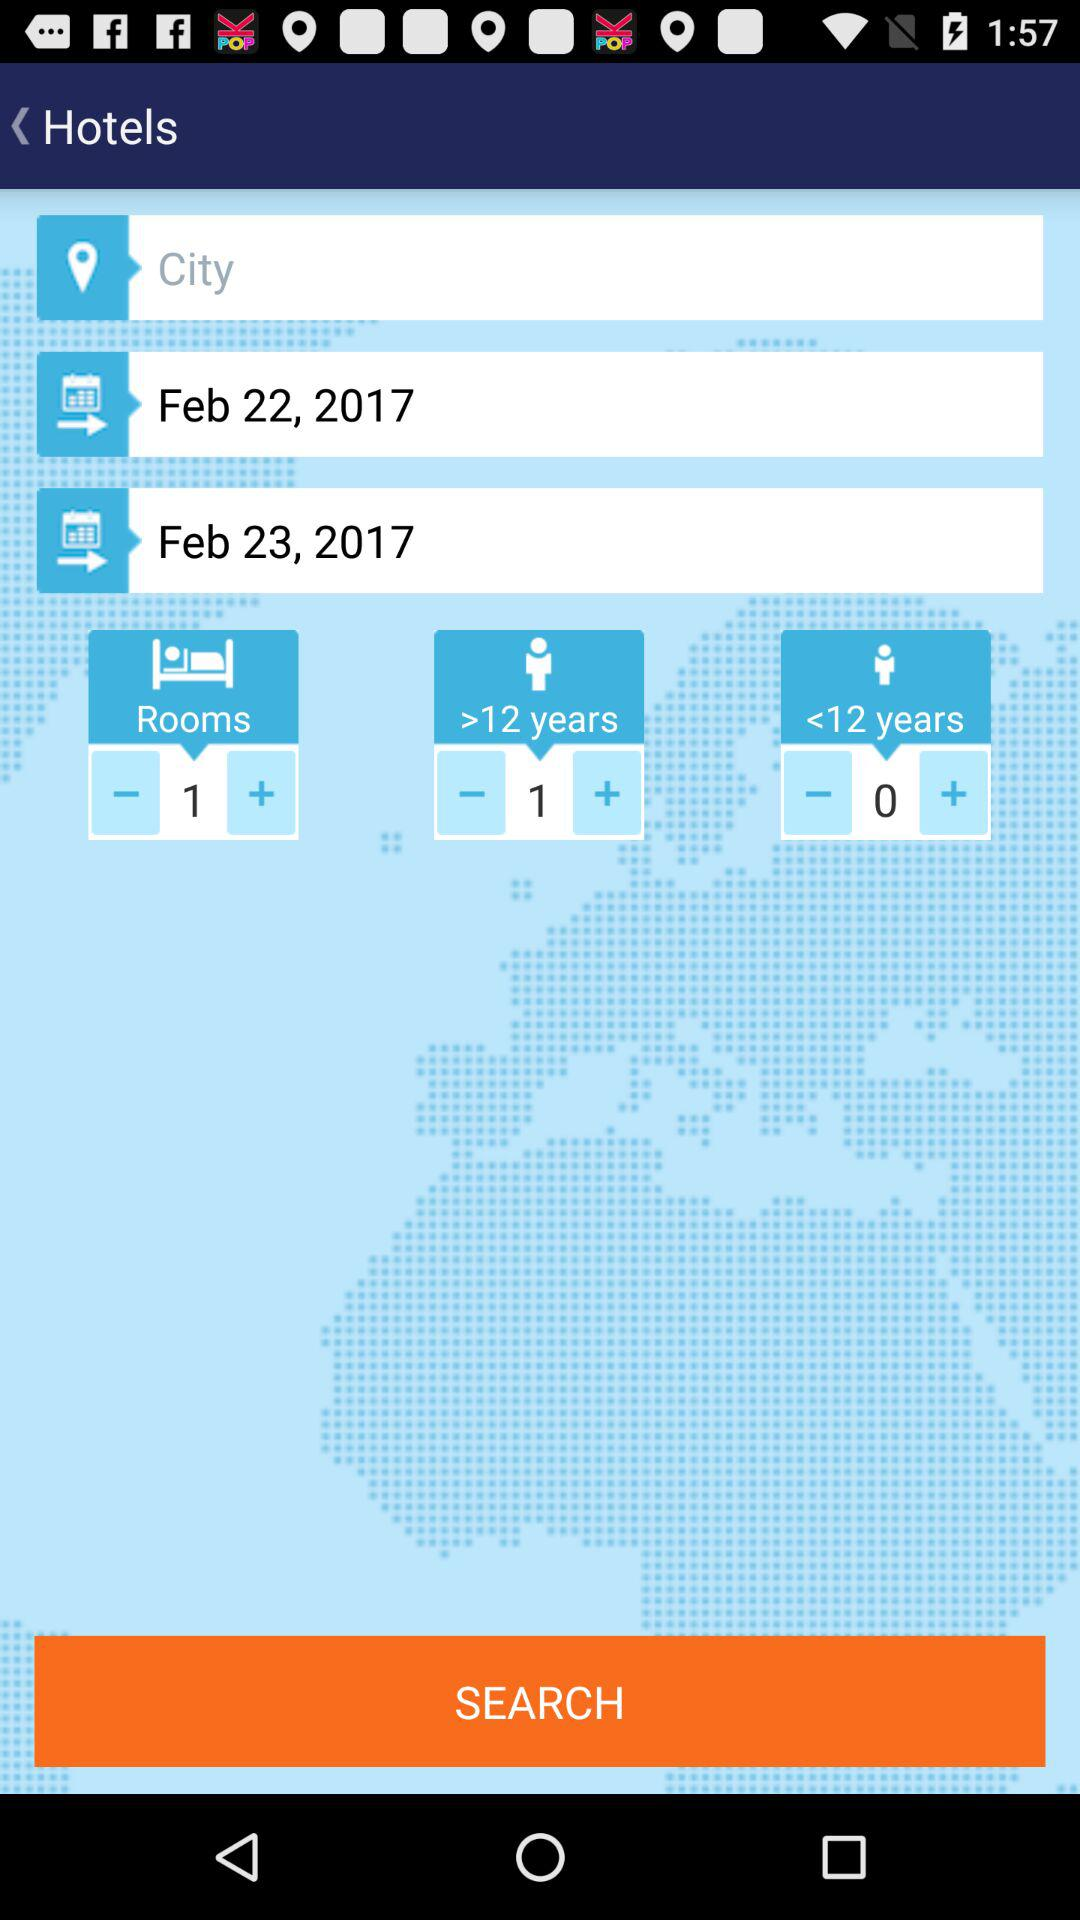What is the check-out date? The check-out date is February 23, 2017. 